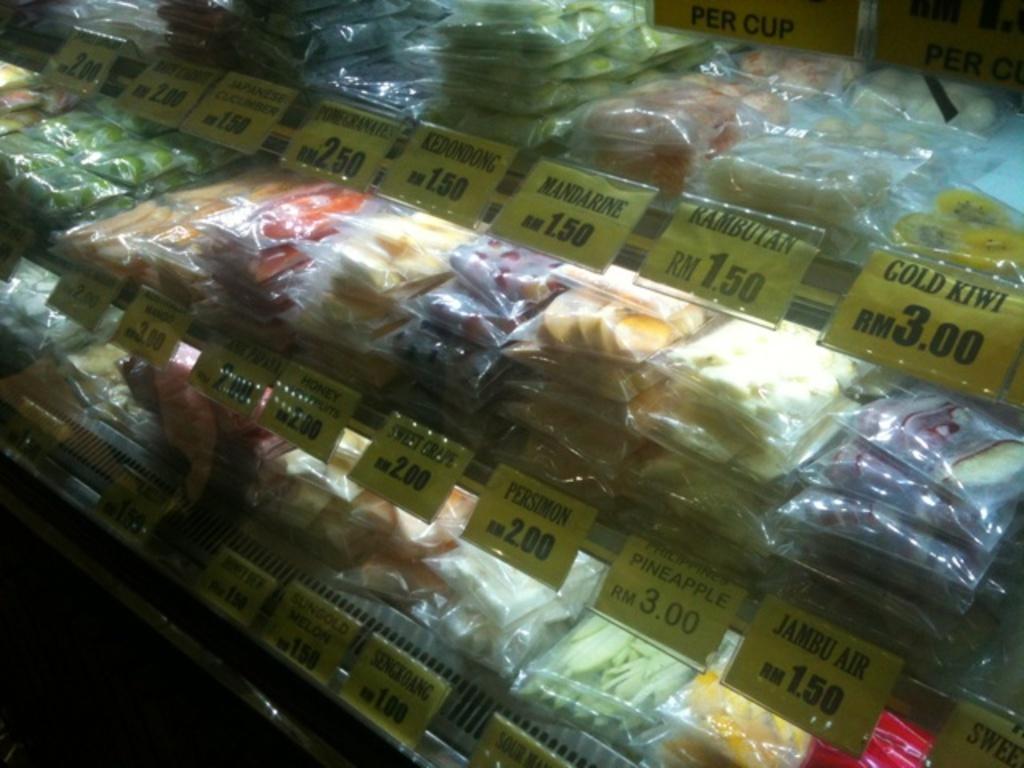Could you give a brief overview of what you see in this image? In this image we can see food packed in the covers and placed in the rack. 